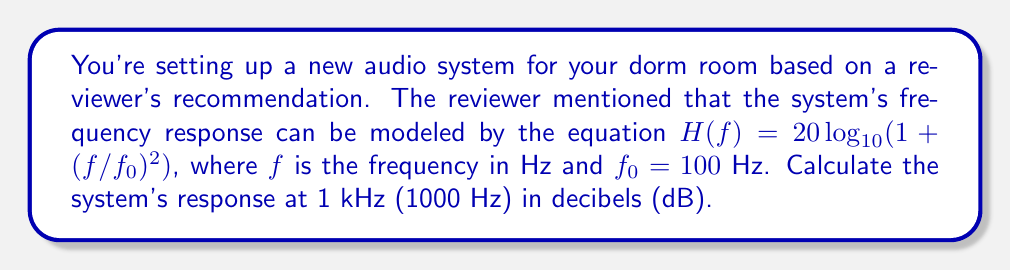Teach me how to tackle this problem. Let's approach this step-by-step:

1) We're given the equation for the frequency response:
   $$H(f) = 20 \log_{10}(1 + (f/f_0)^2)$$

2) We know that $f_0 = 100$ Hz and we need to calculate the response at $f = 1000$ Hz.

3) Let's substitute these values into the equation:
   $$H(1000) = 20 \log_{10}(1 + (1000/100)^2)$$

4) Simplify inside the parentheses:
   $$H(1000) = 20 \log_{10}(1 + 10^2)$$

5) Calculate $10^2 = 100$:
   $$H(1000) = 20 \log_{10}(1 + 100)$$

6) Add inside the parentheses:
   $$H(1000) = 20 \log_{10}(101)$$

7) Use a calculator to compute $\log_{10}(101) \approx 2.00432137378$

8) Multiply by 20:
   $$H(1000) \approx 20 * 2.00432137378 = 40.0864274756$$

9) Round to two decimal places as this is typically sufficient for audio measurements.
Answer: $40.09$ dB 